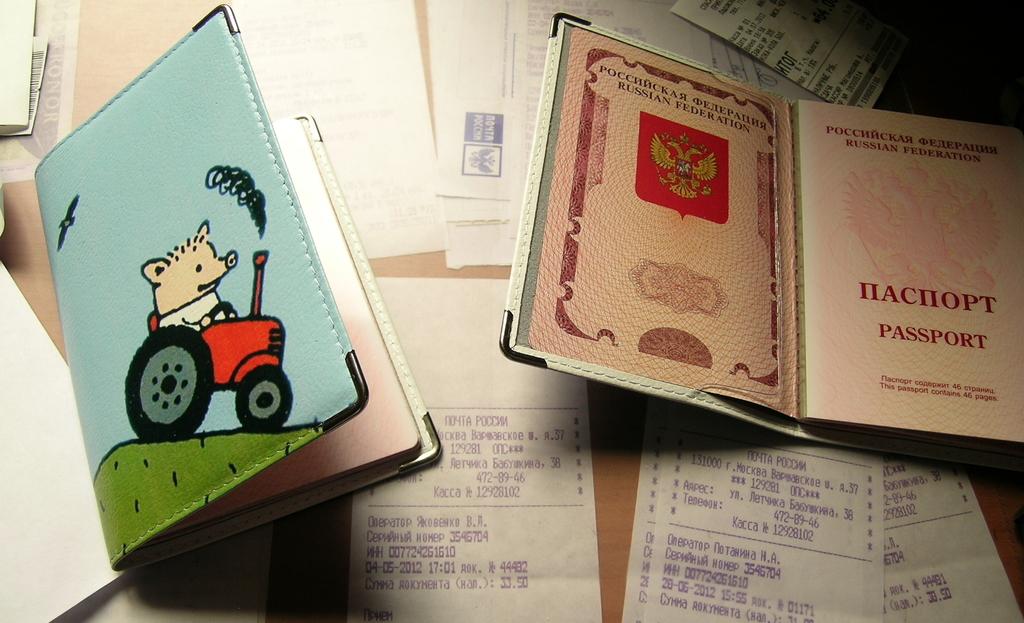Whats the books of?
Ensure brevity in your answer.  Passport. 